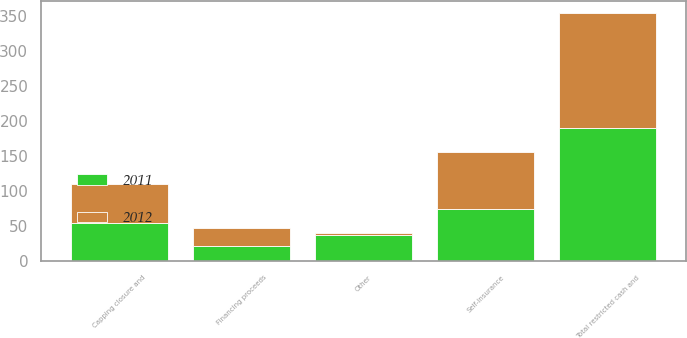<chart> <loc_0><loc_0><loc_500><loc_500><stacked_bar_chart><ecel><fcel>Financing proceeds<fcel>Capping closure and<fcel>Self-insurance<fcel>Other<fcel>Total restricted cash and<nl><fcel>2012<fcel>24.7<fcel>54.8<fcel>81.3<fcel>3.4<fcel>164.2<nl><fcel>2011<fcel>22.5<fcel>54.9<fcel>75.2<fcel>37<fcel>189.6<nl></chart> 